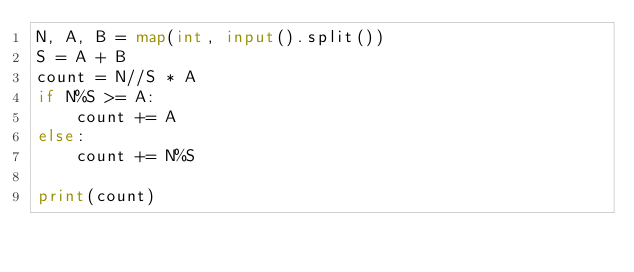Convert code to text. <code><loc_0><loc_0><loc_500><loc_500><_Python_>N, A, B = map(int, input().split())
S = A + B
count = N//S * A
if N%S >= A:
    count += A
else:
    count += N%S

print(count)</code> 